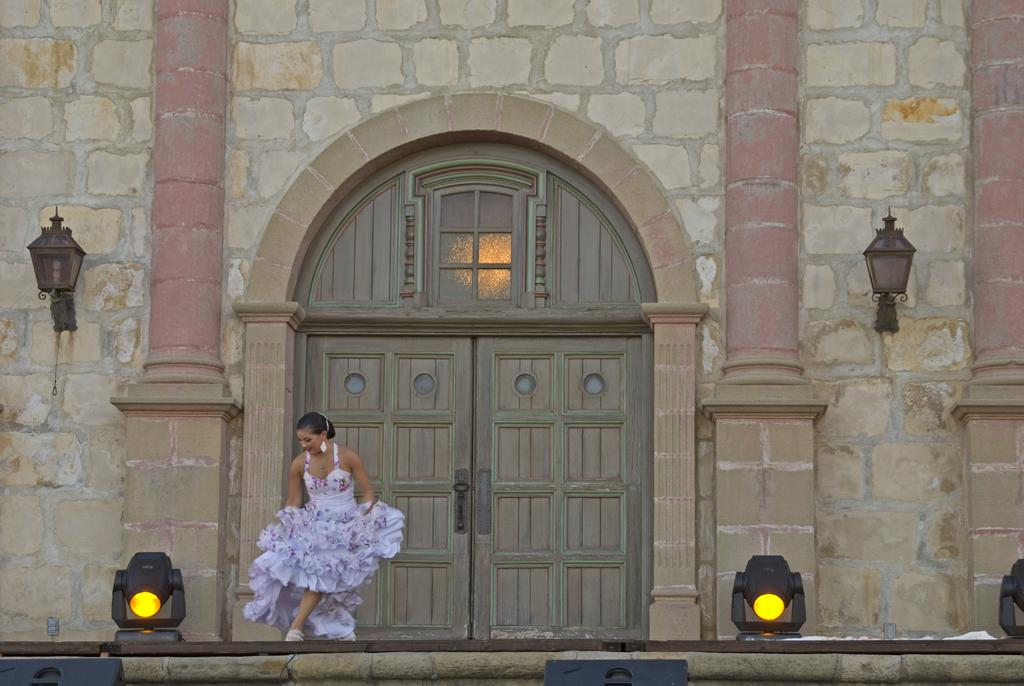What is the main subject of the image? There is a woman standing in the image. What type of lighting is present in the image? There are show lights in the image. What type of structure is depicted in the image? The image appears to depict a building. What type of door can be seen in the image? There is a wooden door in the image. What type of lighting is attached to the building wall in the image? There are lamps attached to the building wall in the image. How many men are playing in the field in the image? There are no men or fields present in the image. What is the cent doing in the image? There is no cent present in the image. 